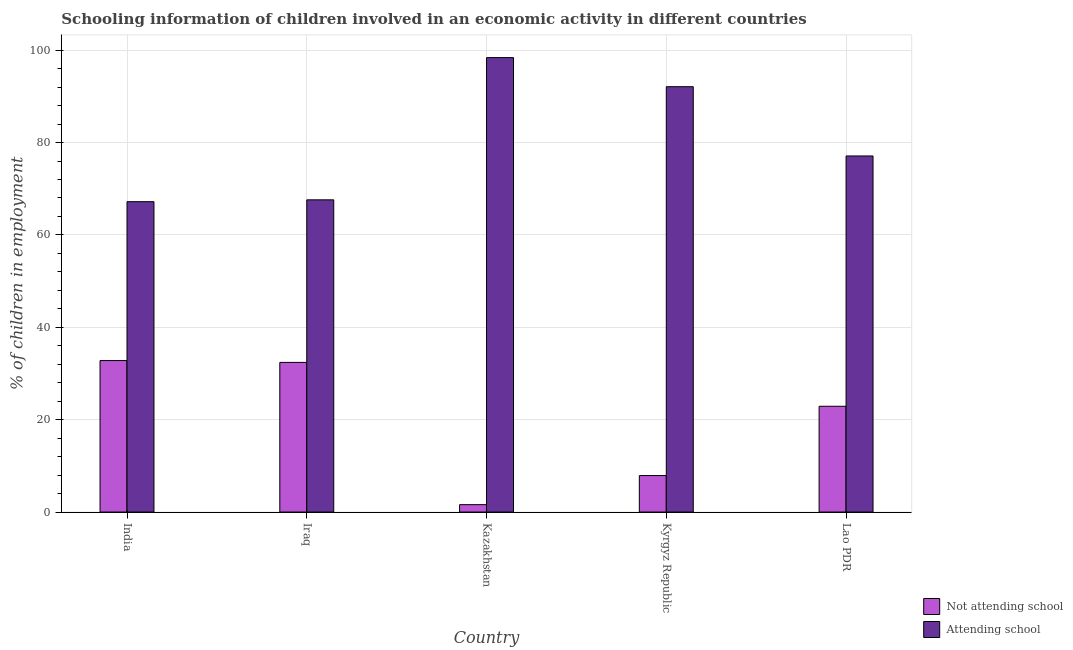How many different coloured bars are there?
Ensure brevity in your answer.  2. Are the number of bars per tick equal to the number of legend labels?
Keep it short and to the point. Yes. Are the number of bars on each tick of the X-axis equal?
Provide a short and direct response. Yes. How many bars are there on the 5th tick from the right?
Your answer should be compact. 2. What is the label of the 4th group of bars from the left?
Your answer should be very brief. Kyrgyz Republic. What is the percentage of employed children who are attending school in Kazakhstan?
Keep it short and to the point. 98.4. Across all countries, what is the maximum percentage of employed children who are not attending school?
Make the answer very short. 32.8. Across all countries, what is the minimum percentage of employed children who are not attending school?
Your response must be concise. 1.6. What is the total percentage of employed children who are attending school in the graph?
Your response must be concise. 402.4. What is the difference between the percentage of employed children who are not attending school in India and that in Kazakhstan?
Provide a short and direct response. 31.2. What is the difference between the percentage of employed children who are not attending school in Kazakhstan and the percentage of employed children who are attending school in Kyrgyz Republic?
Ensure brevity in your answer.  -90.5. What is the average percentage of employed children who are not attending school per country?
Provide a succinct answer. 19.52. What is the difference between the percentage of employed children who are attending school and percentage of employed children who are not attending school in Iraq?
Ensure brevity in your answer.  35.2. What is the ratio of the percentage of employed children who are attending school in Kyrgyz Republic to that in Lao PDR?
Give a very brief answer. 1.19. Is the percentage of employed children who are attending school in India less than that in Lao PDR?
Offer a terse response. Yes. Is the difference between the percentage of employed children who are attending school in Kazakhstan and Lao PDR greater than the difference between the percentage of employed children who are not attending school in Kazakhstan and Lao PDR?
Your response must be concise. Yes. What is the difference between the highest and the second highest percentage of employed children who are attending school?
Your answer should be very brief. 6.3. What is the difference between the highest and the lowest percentage of employed children who are not attending school?
Give a very brief answer. 31.2. Is the sum of the percentage of employed children who are not attending school in India and Kazakhstan greater than the maximum percentage of employed children who are attending school across all countries?
Give a very brief answer. No. What does the 2nd bar from the left in Kyrgyz Republic represents?
Your answer should be compact. Attending school. What does the 2nd bar from the right in India represents?
Your response must be concise. Not attending school. Are all the bars in the graph horizontal?
Make the answer very short. No. Are the values on the major ticks of Y-axis written in scientific E-notation?
Your answer should be very brief. No. How many legend labels are there?
Provide a short and direct response. 2. How are the legend labels stacked?
Ensure brevity in your answer.  Vertical. What is the title of the graph?
Offer a very short reply. Schooling information of children involved in an economic activity in different countries. What is the label or title of the X-axis?
Your answer should be compact. Country. What is the label or title of the Y-axis?
Your answer should be very brief. % of children in employment. What is the % of children in employment in Not attending school in India?
Your answer should be compact. 32.8. What is the % of children in employment of Attending school in India?
Make the answer very short. 67.2. What is the % of children in employment of Not attending school in Iraq?
Offer a very short reply. 32.4. What is the % of children in employment in Attending school in Iraq?
Ensure brevity in your answer.  67.6. What is the % of children in employment of Attending school in Kazakhstan?
Your response must be concise. 98.4. What is the % of children in employment in Attending school in Kyrgyz Republic?
Provide a short and direct response. 92.1. What is the % of children in employment of Not attending school in Lao PDR?
Your response must be concise. 22.9. What is the % of children in employment in Attending school in Lao PDR?
Your response must be concise. 77.1. Across all countries, what is the maximum % of children in employment of Not attending school?
Offer a very short reply. 32.8. Across all countries, what is the maximum % of children in employment in Attending school?
Your answer should be compact. 98.4. Across all countries, what is the minimum % of children in employment in Not attending school?
Your answer should be compact. 1.6. Across all countries, what is the minimum % of children in employment of Attending school?
Your answer should be very brief. 67.2. What is the total % of children in employment in Not attending school in the graph?
Offer a terse response. 97.6. What is the total % of children in employment of Attending school in the graph?
Keep it short and to the point. 402.4. What is the difference between the % of children in employment in Not attending school in India and that in Iraq?
Offer a very short reply. 0.4. What is the difference between the % of children in employment of Not attending school in India and that in Kazakhstan?
Your answer should be compact. 31.2. What is the difference between the % of children in employment in Attending school in India and that in Kazakhstan?
Offer a very short reply. -31.2. What is the difference between the % of children in employment in Not attending school in India and that in Kyrgyz Republic?
Your answer should be very brief. 24.9. What is the difference between the % of children in employment of Attending school in India and that in Kyrgyz Republic?
Keep it short and to the point. -24.9. What is the difference between the % of children in employment in Not attending school in Iraq and that in Kazakhstan?
Make the answer very short. 30.8. What is the difference between the % of children in employment of Attending school in Iraq and that in Kazakhstan?
Your answer should be compact. -30.8. What is the difference between the % of children in employment in Attending school in Iraq and that in Kyrgyz Republic?
Offer a terse response. -24.5. What is the difference between the % of children in employment of Not attending school in Iraq and that in Lao PDR?
Provide a short and direct response. 9.5. What is the difference between the % of children in employment in Attending school in Iraq and that in Lao PDR?
Provide a succinct answer. -9.5. What is the difference between the % of children in employment in Not attending school in Kazakhstan and that in Kyrgyz Republic?
Give a very brief answer. -6.3. What is the difference between the % of children in employment of Not attending school in Kazakhstan and that in Lao PDR?
Your response must be concise. -21.3. What is the difference between the % of children in employment in Attending school in Kazakhstan and that in Lao PDR?
Give a very brief answer. 21.3. What is the difference between the % of children in employment in Not attending school in Kyrgyz Republic and that in Lao PDR?
Provide a short and direct response. -15. What is the difference between the % of children in employment in Attending school in Kyrgyz Republic and that in Lao PDR?
Provide a succinct answer. 15. What is the difference between the % of children in employment in Not attending school in India and the % of children in employment in Attending school in Iraq?
Keep it short and to the point. -34.8. What is the difference between the % of children in employment in Not attending school in India and the % of children in employment in Attending school in Kazakhstan?
Give a very brief answer. -65.6. What is the difference between the % of children in employment of Not attending school in India and the % of children in employment of Attending school in Kyrgyz Republic?
Offer a terse response. -59.3. What is the difference between the % of children in employment in Not attending school in India and the % of children in employment in Attending school in Lao PDR?
Your answer should be very brief. -44.3. What is the difference between the % of children in employment of Not attending school in Iraq and the % of children in employment of Attending school in Kazakhstan?
Provide a succinct answer. -66. What is the difference between the % of children in employment of Not attending school in Iraq and the % of children in employment of Attending school in Kyrgyz Republic?
Provide a succinct answer. -59.7. What is the difference between the % of children in employment in Not attending school in Iraq and the % of children in employment in Attending school in Lao PDR?
Your response must be concise. -44.7. What is the difference between the % of children in employment in Not attending school in Kazakhstan and the % of children in employment in Attending school in Kyrgyz Republic?
Provide a short and direct response. -90.5. What is the difference between the % of children in employment of Not attending school in Kazakhstan and the % of children in employment of Attending school in Lao PDR?
Give a very brief answer. -75.5. What is the difference between the % of children in employment of Not attending school in Kyrgyz Republic and the % of children in employment of Attending school in Lao PDR?
Ensure brevity in your answer.  -69.2. What is the average % of children in employment in Not attending school per country?
Your answer should be compact. 19.52. What is the average % of children in employment in Attending school per country?
Your answer should be very brief. 80.48. What is the difference between the % of children in employment of Not attending school and % of children in employment of Attending school in India?
Offer a very short reply. -34.4. What is the difference between the % of children in employment of Not attending school and % of children in employment of Attending school in Iraq?
Give a very brief answer. -35.2. What is the difference between the % of children in employment in Not attending school and % of children in employment in Attending school in Kazakhstan?
Offer a very short reply. -96.8. What is the difference between the % of children in employment of Not attending school and % of children in employment of Attending school in Kyrgyz Republic?
Provide a succinct answer. -84.2. What is the difference between the % of children in employment of Not attending school and % of children in employment of Attending school in Lao PDR?
Provide a short and direct response. -54.2. What is the ratio of the % of children in employment of Not attending school in India to that in Iraq?
Provide a short and direct response. 1.01. What is the ratio of the % of children in employment in Not attending school in India to that in Kazakhstan?
Your answer should be compact. 20.5. What is the ratio of the % of children in employment in Attending school in India to that in Kazakhstan?
Your answer should be very brief. 0.68. What is the ratio of the % of children in employment of Not attending school in India to that in Kyrgyz Republic?
Give a very brief answer. 4.15. What is the ratio of the % of children in employment of Attending school in India to that in Kyrgyz Republic?
Provide a short and direct response. 0.73. What is the ratio of the % of children in employment of Not attending school in India to that in Lao PDR?
Your response must be concise. 1.43. What is the ratio of the % of children in employment of Attending school in India to that in Lao PDR?
Your response must be concise. 0.87. What is the ratio of the % of children in employment of Not attending school in Iraq to that in Kazakhstan?
Your answer should be very brief. 20.25. What is the ratio of the % of children in employment in Attending school in Iraq to that in Kazakhstan?
Your response must be concise. 0.69. What is the ratio of the % of children in employment of Not attending school in Iraq to that in Kyrgyz Republic?
Give a very brief answer. 4.1. What is the ratio of the % of children in employment of Attending school in Iraq to that in Kyrgyz Republic?
Offer a very short reply. 0.73. What is the ratio of the % of children in employment in Not attending school in Iraq to that in Lao PDR?
Your answer should be very brief. 1.41. What is the ratio of the % of children in employment of Attending school in Iraq to that in Lao PDR?
Offer a very short reply. 0.88. What is the ratio of the % of children in employment of Not attending school in Kazakhstan to that in Kyrgyz Republic?
Offer a very short reply. 0.2. What is the ratio of the % of children in employment in Attending school in Kazakhstan to that in Kyrgyz Republic?
Offer a terse response. 1.07. What is the ratio of the % of children in employment of Not attending school in Kazakhstan to that in Lao PDR?
Your answer should be very brief. 0.07. What is the ratio of the % of children in employment in Attending school in Kazakhstan to that in Lao PDR?
Give a very brief answer. 1.28. What is the ratio of the % of children in employment in Not attending school in Kyrgyz Republic to that in Lao PDR?
Offer a very short reply. 0.34. What is the ratio of the % of children in employment of Attending school in Kyrgyz Republic to that in Lao PDR?
Provide a succinct answer. 1.19. What is the difference between the highest and the second highest % of children in employment in Not attending school?
Give a very brief answer. 0.4. What is the difference between the highest and the second highest % of children in employment of Attending school?
Make the answer very short. 6.3. What is the difference between the highest and the lowest % of children in employment in Not attending school?
Offer a terse response. 31.2. What is the difference between the highest and the lowest % of children in employment in Attending school?
Keep it short and to the point. 31.2. 